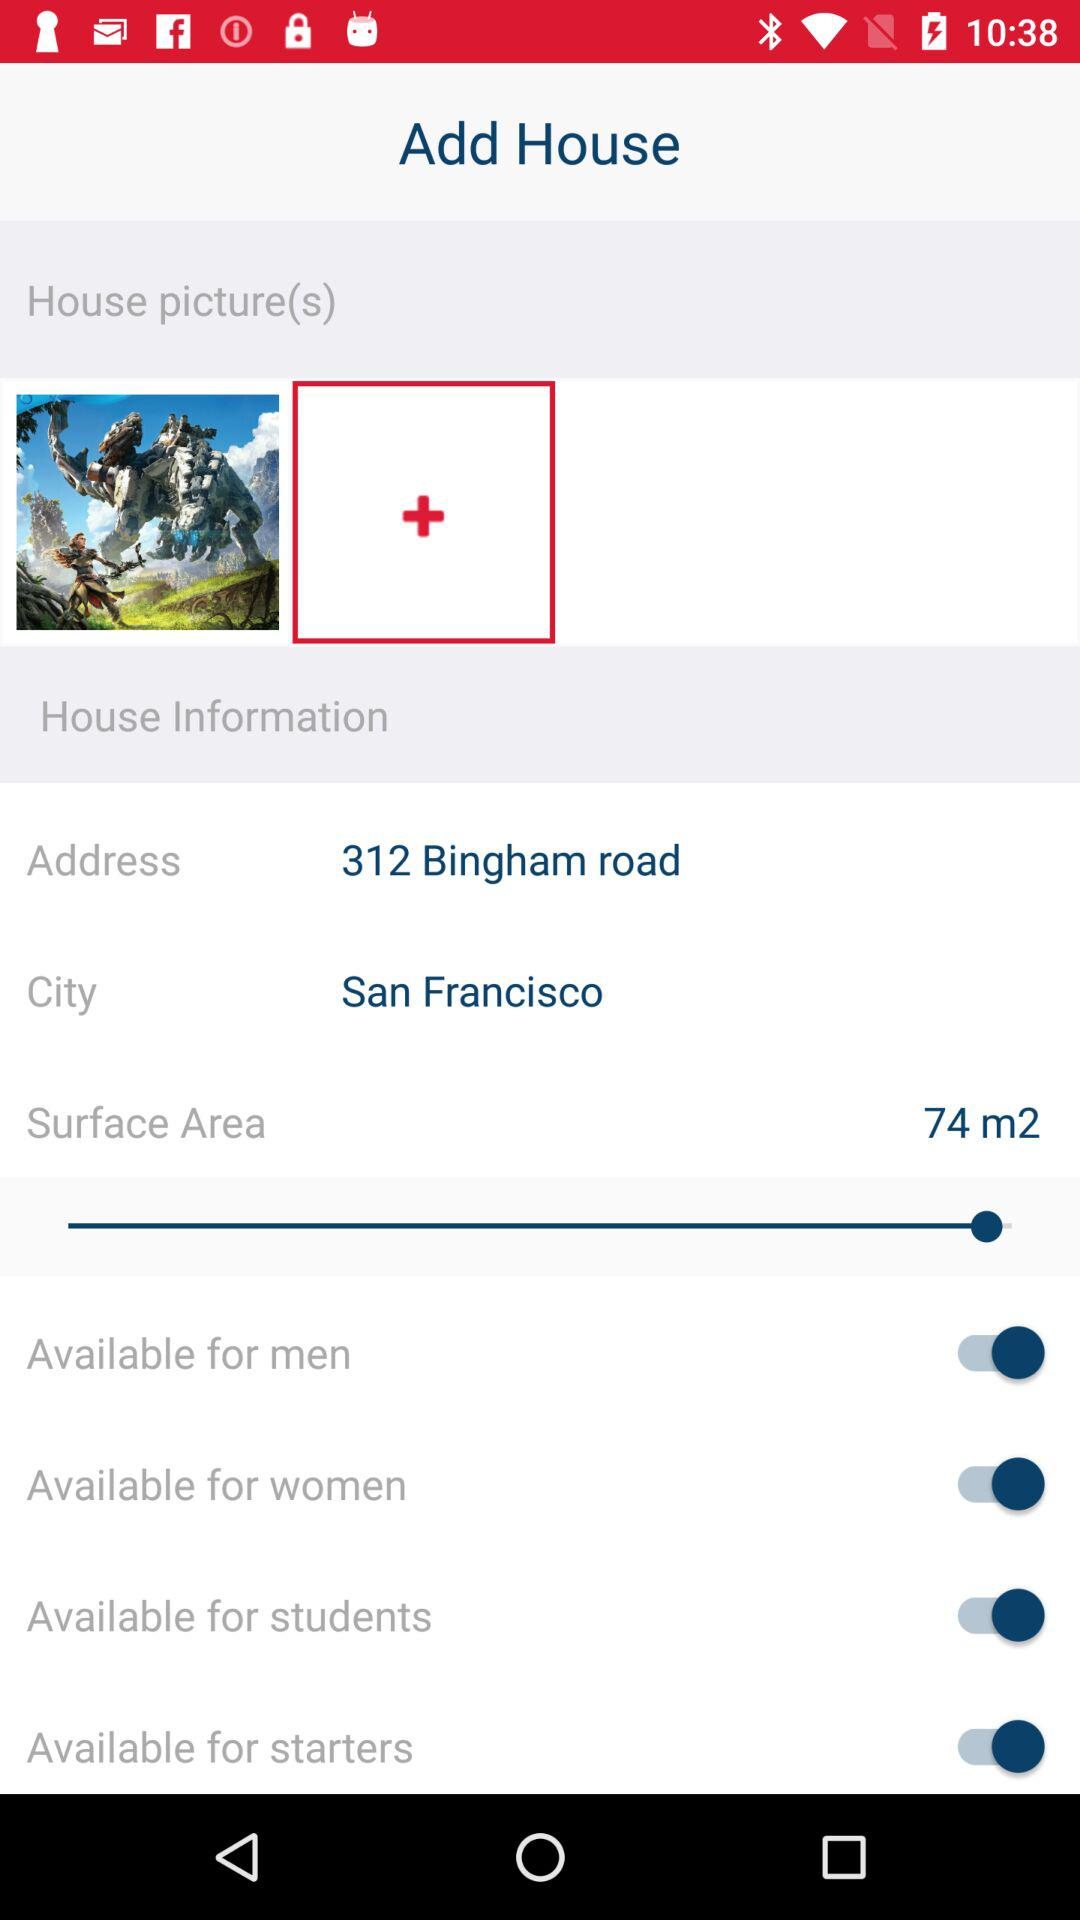What is the surface area? The surface area is 74 square meters. 